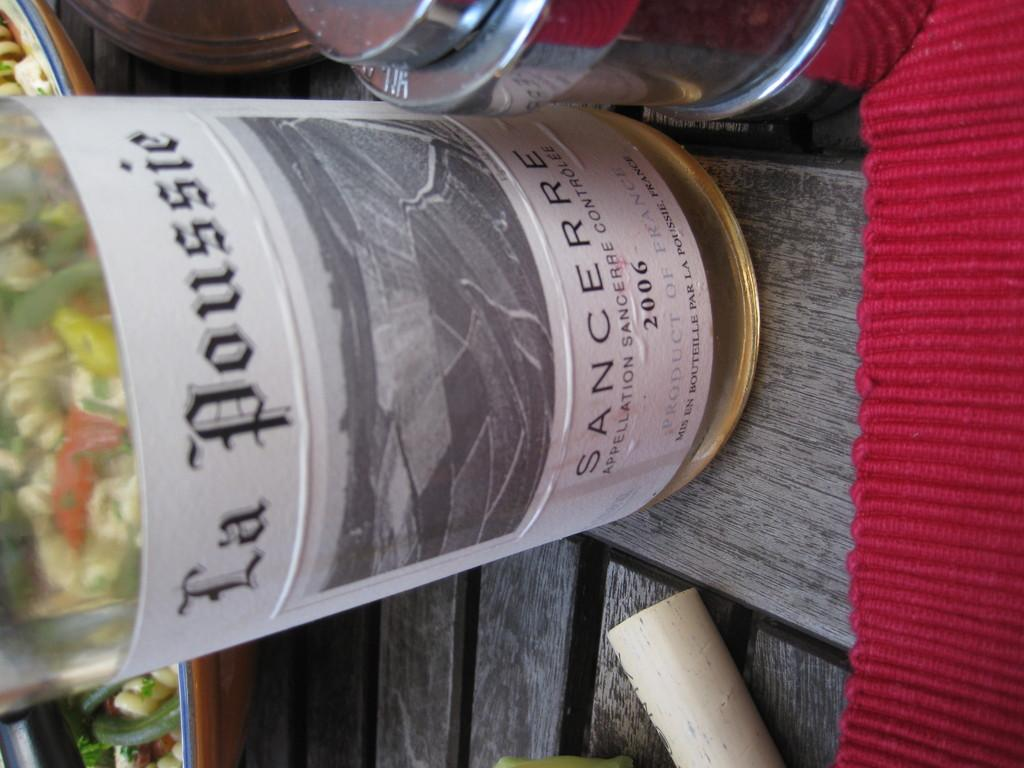<image>
Offer a succinct explanation of the picture presented. A bottle is seen sideways on containing La Poussie white wine. 